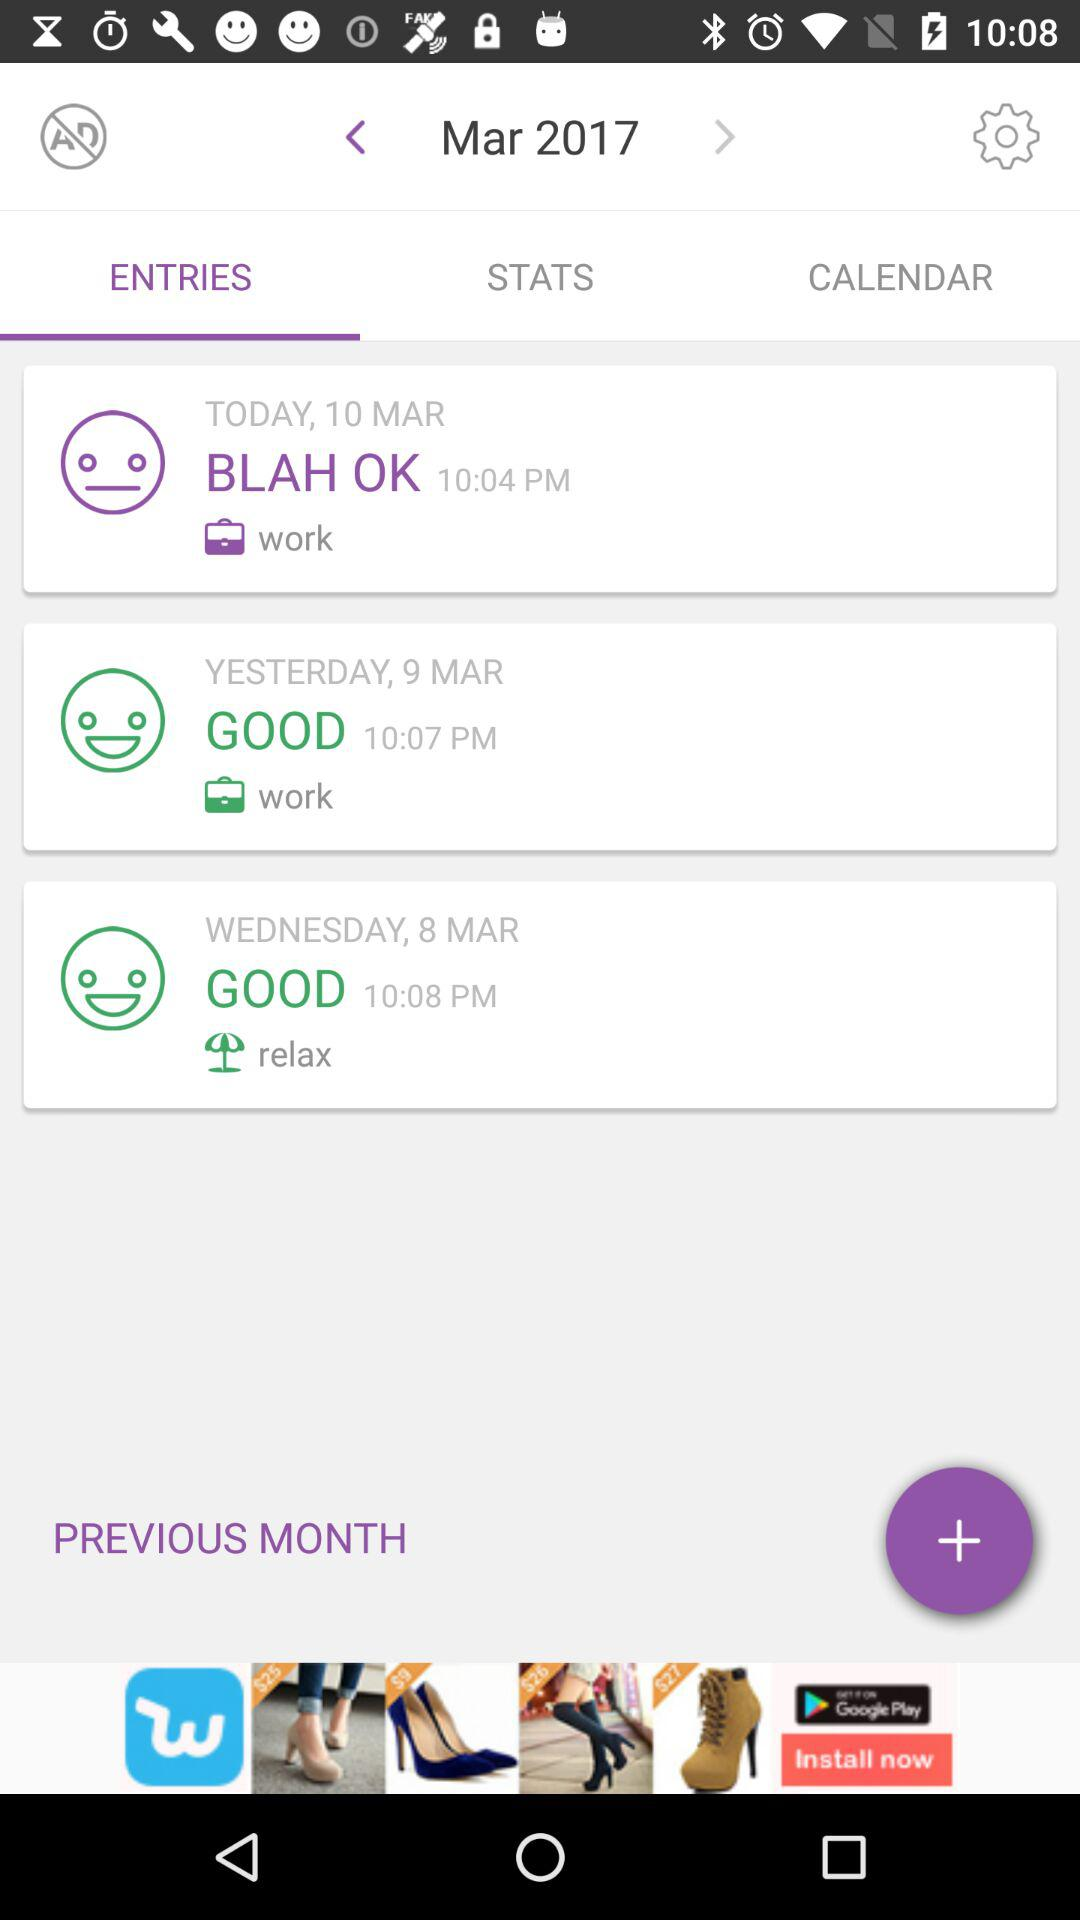Which tab has been selected? The selected tab is "ENTRIES". 